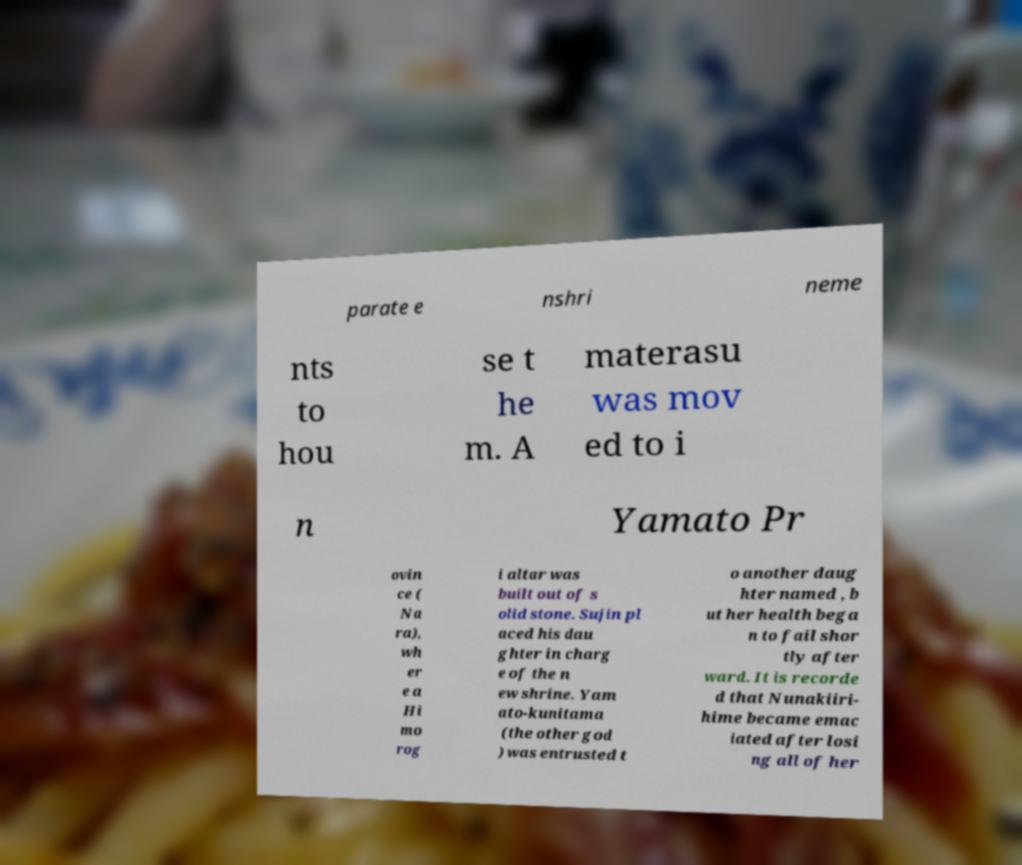Can you read and provide the text displayed in the image?This photo seems to have some interesting text. Can you extract and type it out for me? parate e nshri neme nts to hou se t he m. A materasu was mov ed to i n Yamato Pr ovin ce ( Na ra), wh er e a Hi mo rog i altar was built out of s olid stone. Sujin pl aced his dau ghter in charg e of the n ew shrine. Yam ato-kunitama (the other god ) was entrusted t o another daug hter named , b ut her health bega n to fail shor tly after ward. It is recorde d that Nunakiiri- hime became emac iated after losi ng all of her 